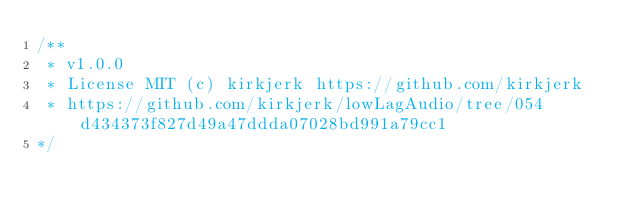Convert code to text. <code><loc_0><loc_0><loc_500><loc_500><_JavaScript_>/**
 * v1.0.0
 * License MIT (c) kirkjerk https://github.com/kirkjerk
 * https://github.com/kirkjerk/lowLagAudio/tree/054d434373f827d49a47ddda07028bd991a79cc1
*/</code> 